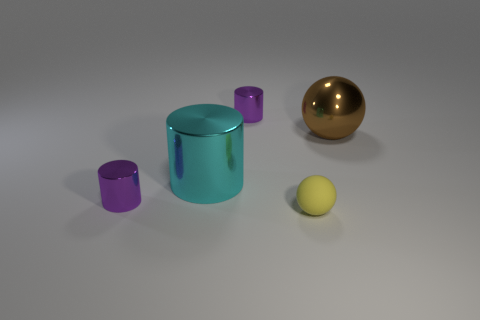Subtract all cyan metallic cylinders. How many cylinders are left? 2 Subtract all brown cubes. How many purple cylinders are left? 2 Subtract all purple cylinders. How many cylinders are left? 1 Add 4 tiny matte objects. How many objects exist? 9 Subtract 1 brown balls. How many objects are left? 4 Subtract all balls. How many objects are left? 3 Subtract all gray cylinders. Subtract all cyan balls. How many cylinders are left? 3 Subtract all tiny green matte cylinders. Subtract all shiny things. How many objects are left? 1 Add 2 yellow rubber objects. How many yellow rubber objects are left? 3 Add 2 purple cylinders. How many purple cylinders exist? 4 